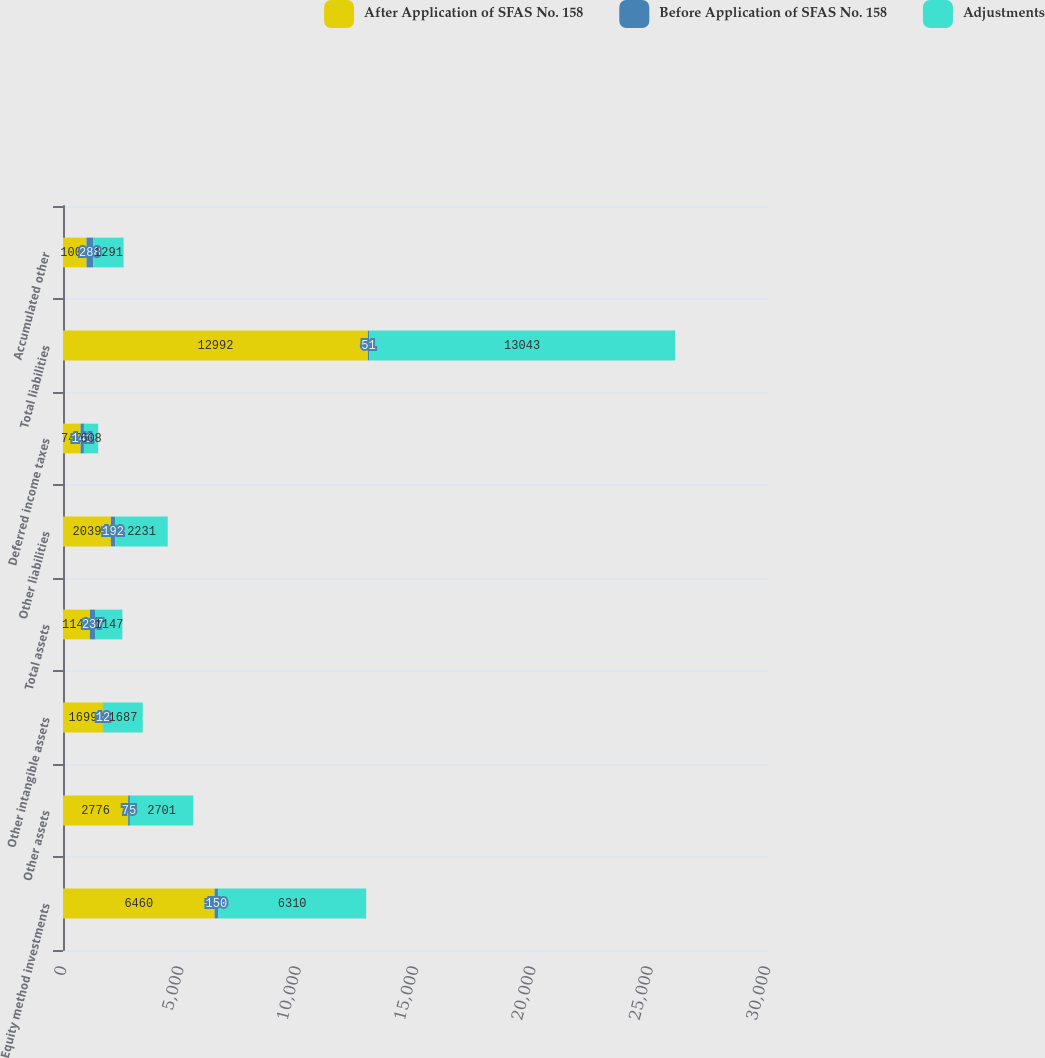<chart> <loc_0><loc_0><loc_500><loc_500><stacked_bar_chart><ecel><fcel>Equity method investments<fcel>Other assets<fcel>Other intangible assets<fcel>Total assets<fcel>Other liabilities<fcel>Deferred income taxes<fcel>Total liabilities<fcel>Accumulated other<nl><fcel>After Application of SFAS No. 158<fcel>6460<fcel>2776<fcel>1699<fcel>1147<fcel>2039<fcel>749<fcel>12992<fcel>1003<nl><fcel>Before Application of SFAS No. 158<fcel>150<fcel>75<fcel>12<fcel>237<fcel>192<fcel>141<fcel>51<fcel>288<nl><fcel>Adjustments<fcel>6310<fcel>2701<fcel>1687<fcel>1147<fcel>2231<fcel>608<fcel>13043<fcel>1291<nl></chart> 